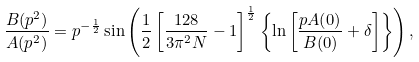<formula> <loc_0><loc_0><loc_500><loc_500>\frac { B ( p ^ { 2 } ) } { A ( p ^ { 2 } ) } = p ^ { - \frac { 1 } { 2 } } \sin \left ( \frac { 1 } { 2 } \left [ \frac { 1 2 8 } { 3 \pi ^ { 2 } N } - 1 \right ] ^ { \frac { 1 } { 2 } } \left \{ \ln \left [ \frac { p A ( 0 ) } { B ( 0 ) } + \delta \right ] \right \} \right ) ,</formula> 